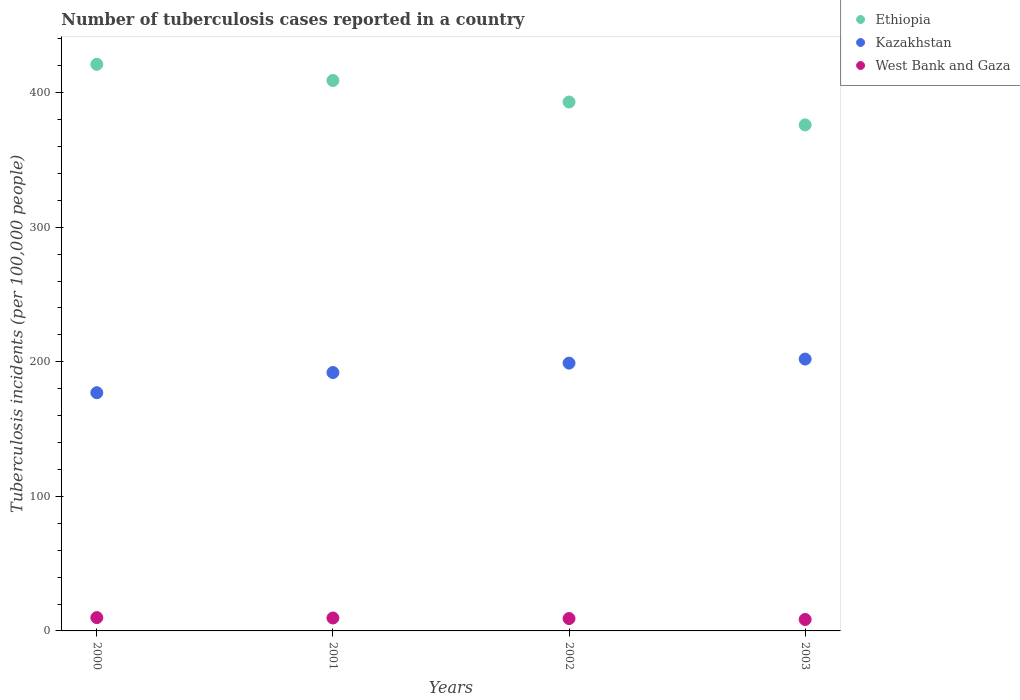How many different coloured dotlines are there?
Give a very brief answer. 3. Is the number of dotlines equal to the number of legend labels?
Your response must be concise. Yes. What is the number of tuberculosis cases reported in in West Bank and Gaza in 2003?
Your answer should be compact. 8.5. Across all years, what is the maximum number of tuberculosis cases reported in in West Bank and Gaza?
Make the answer very short. 9.9. Across all years, what is the minimum number of tuberculosis cases reported in in Ethiopia?
Give a very brief answer. 376. In which year was the number of tuberculosis cases reported in in West Bank and Gaza maximum?
Your answer should be very brief. 2000. What is the total number of tuberculosis cases reported in in West Bank and Gaza in the graph?
Your response must be concise. 37.2. What is the difference between the number of tuberculosis cases reported in in Kazakhstan in 2001 and that in 2002?
Your answer should be compact. -7. What is the difference between the number of tuberculosis cases reported in in Kazakhstan in 2002 and the number of tuberculosis cases reported in in Ethiopia in 2003?
Your answer should be compact. -177. What is the average number of tuberculosis cases reported in in West Bank and Gaza per year?
Your response must be concise. 9.3. In the year 2002, what is the difference between the number of tuberculosis cases reported in in Ethiopia and number of tuberculosis cases reported in in Kazakhstan?
Provide a succinct answer. 194. In how many years, is the number of tuberculosis cases reported in in Kazakhstan greater than 120?
Make the answer very short. 4. What is the ratio of the number of tuberculosis cases reported in in Kazakhstan in 2001 to that in 2003?
Provide a succinct answer. 0.95. Is the difference between the number of tuberculosis cases reported in in Ethiopia in 2002 and 2003 greater than the difference between the number of tuberculosis cases reported in in Kazakhstan in 2002 and 2003?
Provide a short and direct response. Yes. What is the difference between the highest and the second highest number of tuberculosis cases reported in in Kazakhstan?
Your answer should be compact. 3. What is the difference between the highest and the lowest number of tuberculosis cases reported in in Kazakhstan?
Give a very brief answer. 25. In how many years, is the number of tuberculosis cases reported in in West Bank and Gaza greater than the average number of tuberculosis cases reported in in West Bank and Gaza taken over all years?
Your answer should be compact. 2. Is the sum of the number of tuberculosis cases reported in in West Bank and Gaza in 2000 and 2001 greater than the maximum number of tuberculosis cases reported in in Ethiopia across all years?
Your answer should be compact. No. Is it the case that in every year, the sum of the number of tuberculosis cases reported in in Kazakhstan and number of tuberculosis cases reported in in West Bank and Gaza  is greater than the number of tuberculosis cases reported in in Ethiopia?
Your response must be concise. No. How many years are there in the graph?
Offer a very short reply. 4. What is the difference between two consecutive major ticks on the Y-axis?
Keep it short and to the point. 100. Does the graph contain any zero values?
Your response must be concise. No. Where does the legend appear in the graph?
Offer a terse response. Top right. How are the legend labels stacked?
Make the answer very short. Vertical. What is the title of the graph?
Ensure brevity in your answer.  Number of tuberculosis cases reported in a country. Does "Chad" appear as one of the legend labels in the graph?
Offer a very short reply. No. What is the label or title of the X-axis?
Keep it short and to the point. Years. What is the label or title of the Y-axis?
Your answer should be compact. Tuberculosis incidents (per 100,0 people). What is the Tuberculosis incidents (per 100,000 people) of Ethiopia in 2000?
Your answer should be very brief. 421. What is the Tuberculosis incidents (per 100,000 people) of Kazakhstan in 2000?
Make the answer very short. 177. What is the Tuberculosis incidents (per 100,000 people) in Ethiopia in 2001?
Provide a short and direct response. 409. What is the Tuberculosis incidents (per 100,000 people) in Kazakhstan in 2001?
Ensure brevity in your answer.  192. What is the Tuberculosis incidents (per 100,000 people) in Ethiopia in 2002?
Offer a very short reply. 393. What is the Tuberculosis incidents (per 100,000 people) of Kazakhstan in 2002?
Your answer should be very brief. 199. What is the Tuberculosis incidents (per 100,000 people) of West Bank and Gaza in 2002?
Give a very brief answer. 9.2. What is the Tuberculosis incidents (per 100,000 people) in Ethiopia in 2003?
Give a very brief answer. 376. What is the Tuberculosis incidents (per 100,000 people) of Kazakhstan in 2003?
Give a very brief answer. 202. Across all years, what is the maximum Tuberculosis incidents (per 100,000 people) in Ethiopia?
Your answer should be compact. 421. Across all years, what is the maximum Tuberculosis incidents (per 100,000 people) in Kazakhstan?
Make the answer very short. 202. Across all years, what is the maximum Tuberculosis incidents (per 100,000 people) of West Bank and Gaza?
Offer a terse response. 9.9. Across all years, what is the minimum Tuberculosis incidents (per 100,000 people) of Ethiopia?
Make the answer very short. 376. Across all years, what is the minimum Tuberculosis incidents (per 100,000 people) of Kazakhstan?
Offer a terse response. 177. What is the total Tuberculosis incidents (per 100,000 people) in Ethiopia in the graph?
Provide a succinct answer. 1599. What is the total Tuberculosis incidents (per 100,000 people) of Kazakhstan in the graph?
Give a very brief answer. 770. What is the total Tuberculosis incidents (per 100,000 people) in West Bank and Gaza in the graph?
Provide a succinct answer. 37.2. What is the difference between the Tuberculosis incidents (per 100,000 people) in Ethiopia in 2000 and that in 2001?
Offer a terse response. 12. What is the difference between the Tuberculosis incidents (per 100,000 people) of Kazakhstan in 2000 and that in 2001?
Keep it short and to the point. -15. What is the difference between the Tuberculosis incidents (per 100,000 people) in Kazakhstan in 2000 and that in 2002?
Make the answer very short. -22. What is the difference between the Tuberculosis incidents (per 100,000 people) of West Bank and Gaza in 2000 and that in 2002?
Provide a short and direct response. 0.7. What is the difference between the Tuberculosis incidents (per 100,000 people) of Kazakhstan in 2000 and that in 2003?
Give a very brief answer. -25. What is the difference between the Tuberculosis incidents (per 100,000 people) of West Bank and Gaza in 2000 and that in 2003?
Give a very brief answer. 1.4. What is the difference between the Tuberculosis incidents (per 100,000 people) of Kazakhstan in 2001 and that in 2002?
Provide a short and direct response. -7. What is the difference between the Tuberculosis incidents (per 100,000 people) of West Bank and Gaza in 2001 and that in 2002?
Keep it short and to the point. 0.4. What is the difference between the Tuberculosis incidents (per 100,000 people) of Ethiopia in 2001 and that in 2003?
Provide a succinct answer. 33. What is the difference between the Tuberculosis incidents (per 100,000 people) in Kazakhstan in 2001 and that in 2003?
Your response must be concise. -10. What is the difference between the Tuberculosis incidents (per 100,000 people) of West Bank and Gaza in 2001 and that in 2003?
Offer a terse response. 1.1. What is the difference between the Tuberculosis incidents (per 100,000 people) in Kazakhstan in 2002 and that in 2003?
Offer a terse response. -3. What is the difference between the Tuberculosis incidents (per 100,000 people) in West Bank and Gaza in 2002 and that in 2003?
Provide a succinct answer. 0.7. What is the difference between the Tuberculosis incidents (per 100,000 people) in Ethiopia in 2000 and the Tuberculosis incidents (per 100,000 people) in Kazakhstan in 2001?
Make the answer very short. 229. What is the difference between the Tuberculosis incidents (per 100,000 people) in Ethiopia in 2000 and the Tuberculosis incidents (per 100,000 people) in West Bank and Gaza in 2001?
Ensure brevity in your answer.  411.4. What is the difference between the Tuberculosis incidents (per 100,000 people) in Kazakhstan in 2000 and the Tuberculosis incidents (per 100,000 people) in West Bank and Gaza in 2001?
Offer a terse response. 167.4. What is the difference between the Tuberculosis incidents (per 100,000 people) in Ethiopia in 2000 and the Tuberculosis incidents (per 100,000 people) in Kazakhstan in 2002?
Provide a succinct answer. 222. What is the difference between the Tuberculosis incidents (per 100,000 people) of Ethiopia in 2000 and the Tuberculosis incidents (per 100,000 people) of West Bank and Gaza in 2002?
Your response must be concise. 411.8. What is the difference between the Tuberculosis incidents (per 100,000 people) of Kazakhstan in 2000 and the Tuberculosis incidents (per 100,000 people) of West Bank and Gaza in 2002?
Provide a succinct answer. 167.8. What is the difference between the Tuberculosis incidents (per 100,000 people) of Ethiopia in 2000 and the Tuberculosis incidents (per 100,000 people) of Kazakhstan in 2003?
Provide a short and direct response. 219. What is the difference between the Tuberculosis incidents (per 100,000 people) in Ethiopia in 2000 and the Tuberculosis incidents (per 100,000 people) in West Bank and Gaza in 2003?
Provide a succinct answer. 412.5. What is the difference between the Tuberculosis incidents (per 100,000 people) in Kazakhstan in 2000 and the Tuberculosis incidents (per 100,000 people) in West Bank and Gaza in 2003?
Your answer should be very brief. 168.5. What is the difference between the Tuberculosis incidents (per 100,000 people) in Ethiopia in 2001 and the Tuberculosis incidents (per 100,000 people) in Kazakhstan in 2002?
Your answer should be compact. 210. What is the difference between the Tuberculosis incidents (per 100,000 people) of Ethiopia in 2001 and the Tuberculosis incidents (per 100,000 people) of West Bank and Gaza in 2002?
Keep it short and to the point. 399.8. What is the difference between the Tuberculosis incidents (per 100,000 people) of Kazakhstan in 2001 and the Tuberculosis incidents (per 100,000 people) of West Bank and Gaza in 2002?
Make the answer very short. 182.8. What is the difference between the Tuberculosis incidents (per 100,000 people) of Ethiopia in 2001 and the Tuberculosis incidents (per 100,000 people) of Kazakhstan in 2003?
Your response must be concise. 207. What is the difference between the Tuberculosis incidents (per 100,000 people) of Ethiopia in 2001 and the Tuberculosis incidents (per 100,000 people) of West Bank and Gaza in 2003?
Your answer should be very brief. 400.5. What is the difference between the Tuberculosis incidents (per 100,000 people) in Kazakhstan in 2001 and the Tuberculosis incidents (per 100,000 people) in West Bank and Gaza in 2003?
Your answer should be very brief. 183.5. What is the difference between the Tuberculosis incidents (per 100,000 people) of Ethiopia in 2002 and the Tuberculosis incidents (per 100,000 people) of Kazakhstan in 2003?
Offer a very short reply. 191. What is the difference between the Tuberculosis incidents (per 100,000 people) of Ethiopia in 2002 and the Tuberculosis incidents (per 100,000 people) of West Bank and Gaza in 2003?
Your response must be concise. 384.5. What is the difference between the Tuberculosis incidents (per 100,000 people) of Kazakhstan in 2002 and the Tuberculosis incidents (per 100,000 people) of West Bank and Gaza in 2003?
Ensure brevity in your answer.  190.5. What is the average Tuberculosis incidents (per 100,000 people) in Ethiopia per year?
Provide a succinct answer. 399.75. What is the average Tuberculosis incidents (per 100,000 people) in Kazakhstan per year?
Provide a succinct answer. 192.5. What is the average Tuberculosis incidents (per 100,000 people) of West Bank and Gaza per year?
Keep it short and to the point. 9.3. In the year 2000, what is the difference between the Tuberculosis incidents (per 100,000 people) of Ethiopia and Tuberculosis incidents (per 100,000 people) of Kazakhstan?
Offer a very short reply. 244. In the year 2000, what is the difference between the Tuberculosis incidents (per 100,000 people) in Ethiopia and Tuberculosis incidents (per 100,000 people) in West Bank and Gaza?
Ensure brevity in your answer.  411.1. In the year 2000, what is the difference between the Tuberculosis incidents (per 100,000 people) in Kazakhstan and Tuberculosis incidents (per 100,000 people) in West Bank and Gaza?
Provide a short and direct response. 167.1. In the year 2001, what is the difference between the Tuberculosis incidents (per 100,000 people) in Ethiopia and Tuberculosis incidents (per 100,000 people) in Kazakhstan?
Offer a terse response. 217. In the year 2001, what is the difference between the Tuberculosis incidents (per 100,000 people) in Ethiopia and Tuberculosis incidents (per 100,000 people) in West Bank and Gaza?
Provide a short and direct response. 399.4. In the year 2001, what is the difference between the Tuberculosis incidents (per 100,000 people) of Kazakhstan and Tuberculosis incidents (per 100,000 people) of West Bank and Gaza?
Make the answer very short. 182.4. In the year 2002, what is the difference between the Tuberculosis incidents (per 100,000 people) in Ethiopia and Tuberculosis incidents (per 100,000 people) in Kazakhstan?
Your answer should be very brief. 194. In the year 2002, what is the difference between the Tuberculosis incidents (per 100,000 people) of Ethiopia and Tuberculosis incidents (per 100,000 people) of West Bank and Gaza?
Your response must be concise. 383.8. In the year 2002, what is the difference between the Tuberculosis incidents (per 100,000 people) of Kazakhstan and Tuberculosis incidents (per 100,000 people) of West Bank and Gaza?
Give a very brief answer. 189.8. In the year 2003, what is the difference between the Tuberculosis incidents (per 100,000 people) of Ethiopia and Tuberculosis incidents (per 100,000 people) of Kazakhstan?
Offer a terse response. 174. In the year 2003, what is the difference between the Tuberculosis incidents (per 100,000 people) in Ethiopia and Tuberculosis incidents (per 100,000 people) in West Bank and Gaza?
Provide a short and direct response. 367.5. In the year 2003, what is the difference between the Tuberculosis incidents (per 100,000 people) of Kazakhstan and Tuberculosis incidents (per 100,000 people) of West Bank and Gaza?
Provide a short and direct response. 193.5. What is the ratio of the Tuberculosis incidents (per 100,000 people) of Ethiopia in 2000 to that in 2001?
Make the answer very short. 1.03. What is the ratio of the Tuberculosis incidents (per 100,000 people) in Kazakhstan in 2000 to that in 2001?
Ensure brevity in your answer.  0.92. What is the ratio of the Tuberculosis incidents (per 100,000 people) in West Bank and Gaza in 2000 to that in 2001?
Give a very brief answer. 1.03. What is the ratio of the Tuberculosis incidents (per 100,000 people) of Ethiopia in 2000 to that in 2002?
Your answer should be very brief. 1.07. What is the ratio of the Tuberculosis incidents (per 100,000 people) in Kazakhstan in 2000 to that in 2002?
Ensure brevity in your answer.  0.89. What is the ratio of the Tuberculosis incidents (per 100,000 people) in West Bank and Gaza in 2000 to that in 2002?
Give a very brief answer. 1.08. What is the ratio of the Tuberculosis incidents (per 100,000 people) of Ethiopia in 2000 to that in 2003?
Your response must be concise. 1.12. What is the ratio of the Tuberculosis incidents (per 100,000 people) of Kazakhstan in 2000 to that in 2003?
Provide a short and direct response. 0.88. What is the ratio of the Tuberculosis incidents (per 100,000 people) of West Bank and Gaza in 2000 to that in 2003?
Give a very brief answer. 1.16. What is the ratio of the Tuberculosis incidents (per 100,000 people) in Ethiopia in 2001 to that in 2002?
Your answer should be very brief. 1.04. What is the ratio of the Tuberculosis incidents (per 100,000 people) in Kazakhstan in 2001 to that in 2002?
Provide a succinct answer. 0.96. What is the ratio of the Tuberculosis incidents (per 100,000 people) in West Bank and Gaza in 2001 to that in 2002?
Ensure brevity in your answer.  1.04. What is the ratio of the Tuberculosis incidents (per 100,000 people) of Ethiopia in 2001 to that in 2003?
Give a very brief answer. 1.09. What is the ratio of the Tuberculosis incidents (per 100,000 people) of Kazakhstan in 2001 to that in 2003?
Make the answer very short. 0.95. What is the ratio of the Tuberculosis incidents (per 100,000 people) in West Bank and Gaza in 2001 to that in 2003?
Offer a very short reply. 1.13. What is the ratio of the Tuberculosis incidents (per 100,000 people) of Ethiopia in 2002 to that in 2003?
Your answer should be very brief. 1.05. What is the ratio of the Tuberculosis incidents (per 100,000 people) of Kazakhstan in 2002 to that in 2003?
Make the answer very short. 0.99. What is the ratio of the Tuberculosis incidents (per 100,000 people) in West Bank and Gaza in 2002 to that in 2003?
Your answer should be compact. 1.08. What is the difference between the highest and the second highest Tuberculosis incidents (per 100,000 people) of Kazakhstan?
Provide a succinct answer. 3. What is the difference between the highest and the lowest Tuberculosis incidents (per 100,000 people) in Ethiopia?
Provide a succinct answer. 45. 